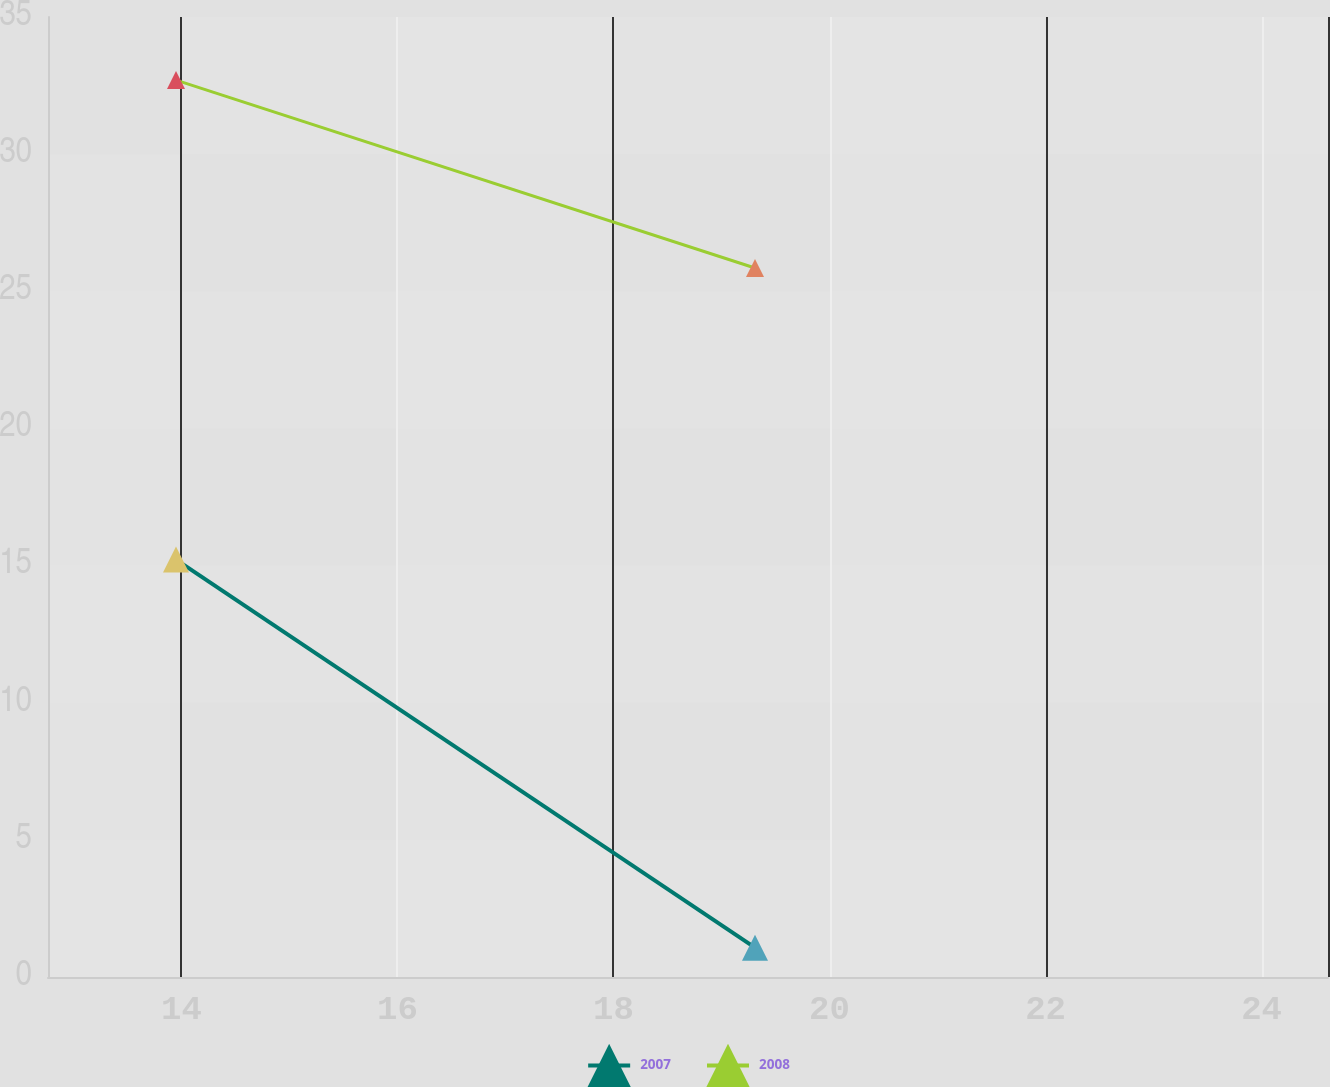Convert chart. <chart><loc_0><loc_0><loc_500><loc_500><line_chart><ecel><fcel>2007<fcel>2008<nl><fcel>13.95<fcel>15.22<fcel>32.7<nl><fcel>19.31<fcel>1.07<fcel>25.85<nl><fcel>25.8<fcel>22.52<fcel>15.28<nl></chart> 